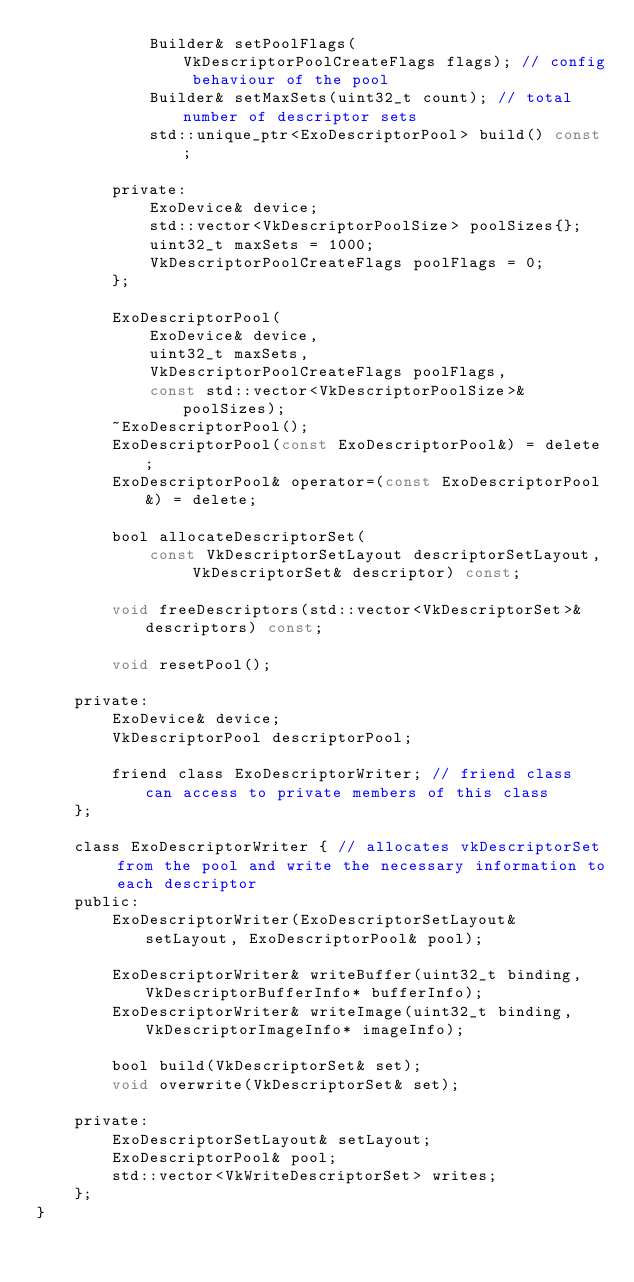Convert code to text. <code><loc_0><loc_0><loc_500><loc_500><_C_>            Builder& setPoolFlags(VkDescriptorPoolCreateFlags flags); // config behaviour of the pool
            Builder& setMaxSets(uint32_t count); // total number of descriptor sets
            std::unique_ptr<ExoDescriptorPool> build() const;

        private:
            ExoDevice& device;
            std::vector<VkDescriptorPoolSize> poolSizes{};
            uint32_t maxSets = 1000;
            VkDescriptorPoolCreateFlags poolFlags = 0;
        };

        ExoDescriptorPool(
            ExoDevice& device,
            uint32_t maxSets,
            VkDescriptorPoolCreateFlags poolFlags,
            const std::vector<VkDescriptorPoolSize>& poolSizes);
        ~ExoDescriptorPool();
        ExoDescriptorPool(const ExoDescriptorPool&) = delete;
        ExoDescriptorPool& operator=(const ExoDescriptorPool&) = delete;

        bool allocateDescriptorSet(
            const VkDescriptorSetLayout descriptorSetLayout, VkDescriptorSet& descriptor) const;

        void freeDescriptors(std::vector<VkDescriptorSet>& descriptors) const;

        void resetPool();

    private:
        ExoDevice& device;
        VkDescriptorPool descriptorPool;

        friend class ExoDescriptorWriter; // friend class can access to private members of this class
    };

    class ExoDescriptorWriter { // allocates vkDescriptorSet from the pool and write the necessary information to each descriptor
    public:
        ExoDescriptorWriter(ExoDescriptorSetLayout& setLayout, ExoDescriptorPool& pool);

        ExoDescriptorWriter& writeBuffer(uint32_t binding, VkDescriptorBufferInfo* bufferInfo);
        ExoDescriptorWriter& writeImage(uint32_t binding, VkDescriptorImageInfo* imageInfo);

        bool build(VkDescriptorSet& set);
        void overwrite(VkDescriptorSet& set);

    private:
        ExoDescriptorSetLayout& setLayout;
        ExoDescriptorPool& pool;
        std::vector<VkWriteDescriptorSet> writes;
    };
}</code> 